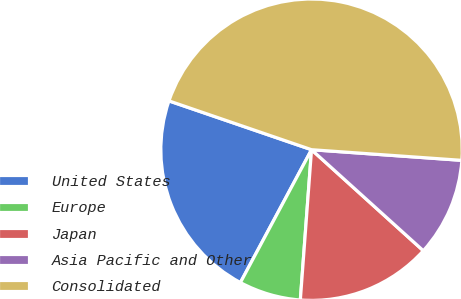Convert chart to OTSL. <chart><loc_0><loc_0><loc_500><loc_500><pie_chart><fcel>United States<fcel>Europe<fcel>Japan<fcel>Asia Pacific and Other<fcel>Consolidated<nl><fcel>22.43%<fcel>6.64%<fcel>14.49%<fcel>10.57%<fcel>45.88%<nl></chart> 